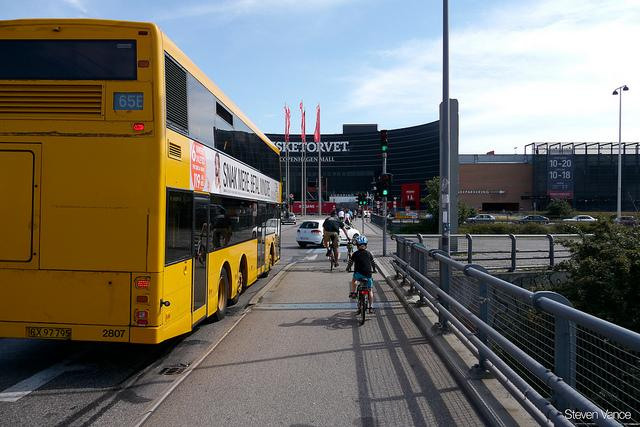What is the full name of the building ahead? fisketorvet 